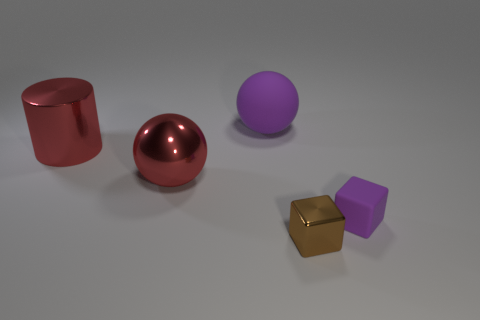Is the small purple thing the same shape as the brown thing?
Ensure brevity in your answer.  Yes. Is there any other thing that has the same shape as the large purple thing?
Make the answer very short. Yes. There is a big object that is in front of the red shiny cylinder; does it have the same color as the small thing that is to the right of the brown metal object?
Keep it short and to the point. No. Are there fewer small brown metallic blocks to the left of the large matte ball than small purple things in front of the tiny purple object?
Give a very brief answer. No. What is the shape of the purple object to the left of the small purple matte thing?
Your answer should be compact. Sphere. There is a large sphere that is the same color as the small matte cube; what material is it?
Keep it short and to the point. Rubber. What number of other things are there of the same material as the tiny purple cube
Offer a very short reply. 1. There is a big purple thing; does it have the same shape as the red thing that is to the right of the large cylinder?
Offer a terse response. Yes. What shape is the big object that is made of the same material as the big red ball?
Provide a succinct answer. Cylinder. Are there more red balls in front of the purple cube than large metal spheres that are right of the big matte thing?
Ensure brevity in your answer.  No. 